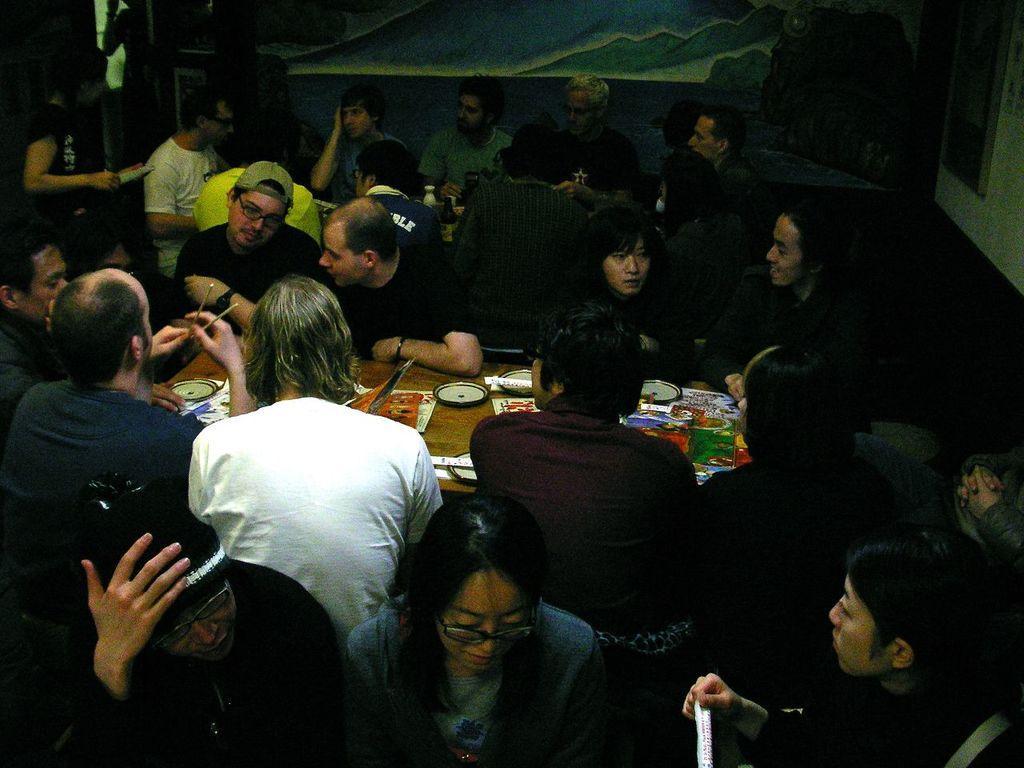In one or two sentences, can you explain what this image depicts? In the image I can see number of persons are sitting on chairs around the brown colored table and on the table I can see few plates and few other objects. I can see a person standing, the wall and few other objects. 